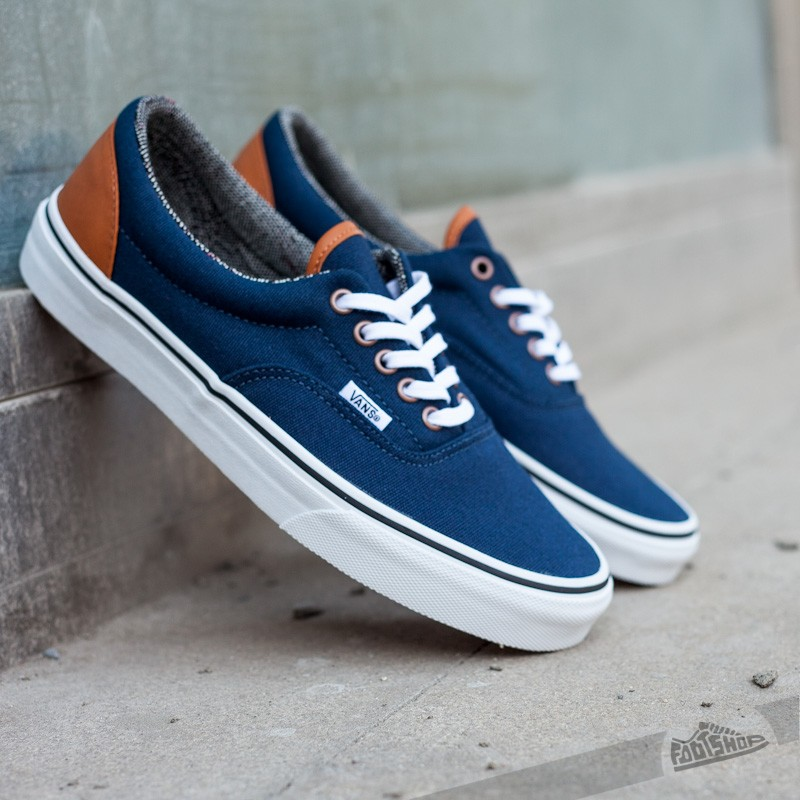Create possible outfit inspirations that go well with these sneakers for various occasions. For a casual day out: Pair the sneakers with classic blue jeans, a white t-shirt, and a denim jacket. Add a brown leather belt to harmonize with the sneaker's accents and a pair of aviator sunglasses to complete the look. For a semi-formal occasion: Wear the sneakers with navy chinos and a light blue button-down shirt. Top it off with a grey blazer to keep it sleek yet approachable. For a sporty look: Match the sneakers with grey joggers, a black athletic tank, and a lightweight zip-up hoodie. A sports watch will add a nice touch as you head out for a walk or to the gym. 